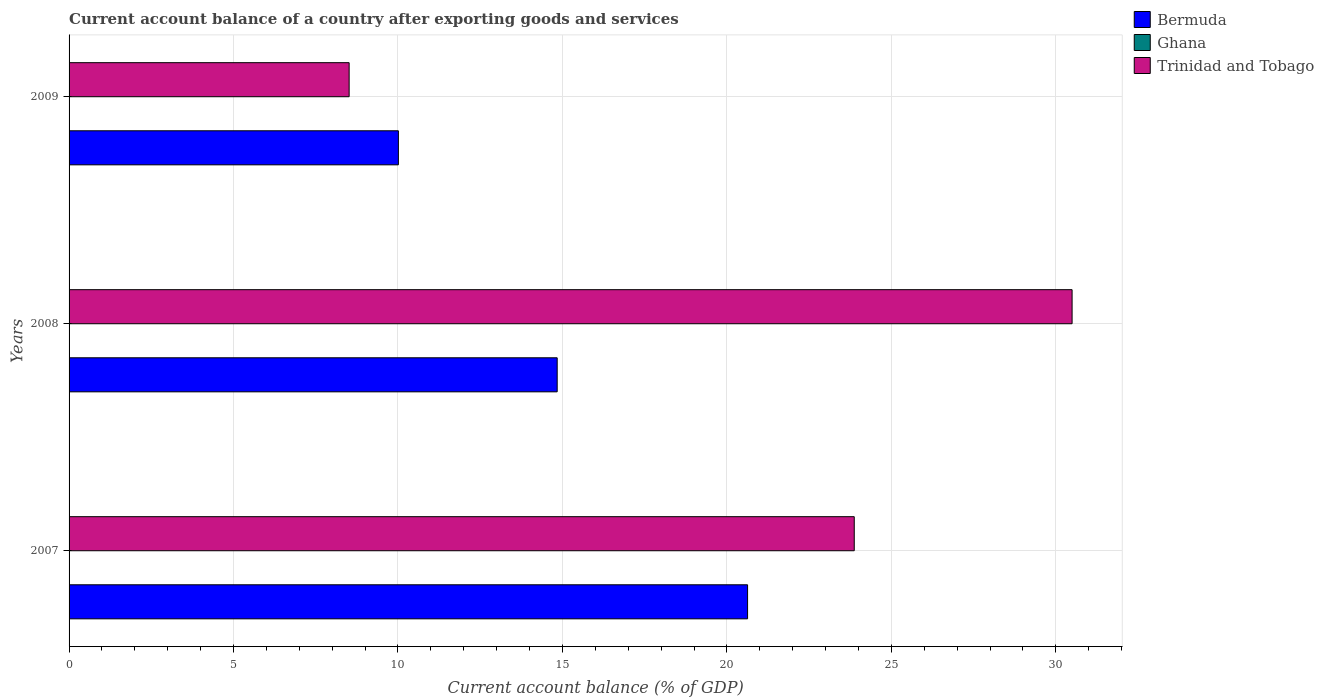How many groups of bars are there?
Ensure brevity in your answer.  3. Are the number of bars on each tick of the Y-axis equal?
Your answer should be very brief. Yes. How many bars are there on the 2nd tick from the top?
Give a very brief answer. 2. What is the label of the 3rd group of bars from the top?
Make the answer very short. 2007. In how many cases, is the number of bars for a given year not equal to the number of legend labels?
Give a very brief answer. 3. What is the account balance in Bermuda in 2007?
Keep it short and to the point. 20.63. Across all years, what is the maximum account balance in Trinidad and Tobago?
Provide a succinct answer. 30.5. Across all years, what is the minimum account balance in Trinidad and Tobago?
Make the answer very short. 8.52. What is the difference between the account balance in Trinidad and Tobago in 2007 and that in 2009?
Your answer should be compact. 15.36. What is the difference between the account balance in Bermuda in 2008 and the account balance in Trinidad and Tobago in 2007?
Offer a terse response. -9.03. In the year 2009, what is the difference between the account balance in Trinidad and Tobago and account balance in Bermuda?
Offer a terse response. -1.5. What is the ratio of the account balance in Bermuda in 2007 to that in 2008?
Offer a very short reply. 1.39. Is the account balance in Trinidad and Tobago in 2007 less than that in 2009?
Offer a terse response. No. What is the difference between the highest and the second highest account balance in Bermuda?
Your answer should be very brief. 5.79. What is the difference between the highest and the lowest account balance in Bermuda?
Your answer should be very brief. 10.62. In how many years, is the account balance in Trinidad and Tobago greater than the average account balance in Trinidad and Tobago taken over all years?
Your response must be concise. 2. Is it the case that in every year, the sum of the account balance in Bermuda and account balance in Trinidad and Tobago is greater than the account balance in Ghana?
Offer a terse response. Yes. How many bars are there?
Make the answer very short. 6. How many years are there in the graph?
Give a very brief answer. 3. What is the difference between two consecutive major ticks on the X-axis?
Offer a terse response. 5. Are the values on the major ticks of X-axis written in scientific E-notation?
Your response must be concise. No. How are the legend labels stacked?
Keep it short and to the point. Vertical. What is the title of the graph?
Provide a succinct answer. Current account balance of a country after exporting goods and services. What is the label or title of the X-axis?
Provide a succinct answer. Current account balance (% of GDP). What is the label or title of the Y-axis?
Provide a succinct answer. Years. What is the Current account balance (% of GDP) in Bermuda in 2007?
Offer a very short reply. 20.63. What is the Current account balance (% of GDP) in Trinidad and Tobago in 2007?
Offer a terse response. 23.87. What is the Current account balance (% of GDP) in Bermuda in 2008?
Give a very brief answer. 14.84. What is the Current account balance (% of GDP) of Ghana in 2008?
Offer a very short reply. 0. What is the Current account balance (% of GDP) of Trinidad and Tobago in 2008?
Offer a very short reply. 30.5. What is the Current account balance (% of GDP) of Bermuda in 2009?
Provide a short and direct response. 10.01. What is the Current account balance (% of GDP) in Ghana in 2009?
Provide a short and direct response. 0. What is the Current account balance (% of GDP) in Trinidad and Tobago in 2009?
Your answer should be compact. 8.52. Across all years, what is the maximum Current account balance (% of GDP) of Bermuda?
Your answer should be compact. 20.63. Across all years, what is the maximum Current account balance (% of GDP) of Trinidad and Tobago?
Provide a short and direct response. 30.5. Across all years, what is the minimum Current account balance (% of GDP) in Bermuda?
Make the answer very short. 10.01. Across all years, what is the minimum Current account balance (% of GDP) of Trinidad and Tobago?
Ensure brevity in your answer.  8.52. What is the total Current account balance (% of GDP) in Bermuda in the graph?
Offer a very short reply. 45.48. What is the total Current account balance (% of GDP) in Trinidad and Tobago in the graph?
Make the answer very short. 62.88. What is the difference between the Current account balance (% of GDP) in Bermuda in 2007 and that in 2008?
Ensure brevity in your answer.  5.79. What is the difference between the Current account balance (% of GDP) of Trinidad and Tobago in 2007 and that in 2008?
Provide a succinct answer. -6.62. What is the difference between the Current account balance (% of GDP) in Bermuda in 2007 and that in 2009?
Keep it short and to the point. 10.62. What is the difference between the Current account balance (% of GDP) in Trinidad and Tobago in 2007 and that in 2009?
Offer a terse response. 15.36. What is the difference between the Current account balance (% of GDP) in Bermuda in 2008 and that in 2009?
Keep it short and to the point. 4.83. What is the difference between the Current account balance (% of GDP) in Trinidad and Tobago in 2008 and that in 2009?
Offer a terse response. 21.98. What is the difference between the Current account balance (% of GDP) in Bermuda in 2007 and the Current account balance (% of GDP) in Trinidad and Tobago in 2008?
Offer a very short reply. -9.87. What is the difference between the Current account balance (% of GDP) in Bermuda in 2007 and the Current account balance (% of GDP) in Trinidad and Tobago in 2009?
Your response must be concise. 12.11. What is the difference between the Current account balance (% of GDP) of Bermuda in 2008 and the Current account balance (% of GDP) of Trinidad and Tobago in 2009?
Provide a succinct answer. 6.33. What is the average Current account balance (% of GDP) in Bermuda per year?
Your answer should be compact. 15.16. What is the average Current account balance (% of GDP) in Ghana per year?
Make the answer very short. 0. What is the average Current account balance (% of GDP) of Trinidad and Tobago per year?
Provide a short and direct response. 20.96. In the year 2007, what is the difference between the Current account balance (% of GDP) in Bermuda and Current account balance (% of GDP) in Trinidad and Tobago?
Give a very brief answer. -3.24. In the year 2008, what is the difference between the Current account balance (% of GDP) in Bermuda and Current account balance (% of GDP) in Trinidad and Tobago?
Your answer should be very brief. -15.65. In the year 2009, what is the difference between the Current account balance (% of GDP) in Bermuda and Current account balance (% of GDP) in Trinidad and Tobago?
Your response must be concise. 1.5. What is the ratio of the Current account balance (% of GDP) in Bermuda in 2007 to that in 2008?
Your response must be concise. 1.39. What is the ratio of the Current account balance (% of GDP) in Trinidad and Tobago in 2007 to that in 2008?
Your answer should be compact. 0.78. What is the ratio of the Current account balance (% of GDP) of Bermuda in 2007 to that in 2009?
Offer a terse response. 2.06. What is the ratio of the Current account balance (% of GDP) in Trinidad and Tobago in 2007 to that in 2009?
Your answer should be very brief. 2.8. What is the ratio of the Current account balance (% of GDP) of Bermuda in 2008 to that in 2009?
Offer a very short reply. 1.48. What is the ratio of the Current account balance (% of GDP) of Trinidad and Tobago in 2008 to that in 2009?
Give a very brief answer. 3.58. What is the difference between the highest and the second highest Current account balance (% of GDP) in Bermuda?
Provide a short and direct response. 5.79. What is the difference between the highest and the second highest Current account balance (% of GDP) in Trinidad and Tobago?
Provide a short and direct response. 6.62. What is the difference between the highest and the lowest Current account balance (% of GDP) in Bermuda?
Offer a terse response. 10.62. What is the difference between the highest and the lowest Current account balance (% of GDP) in Trinidad and Tobago?
Your response must be concise. 21.98. 